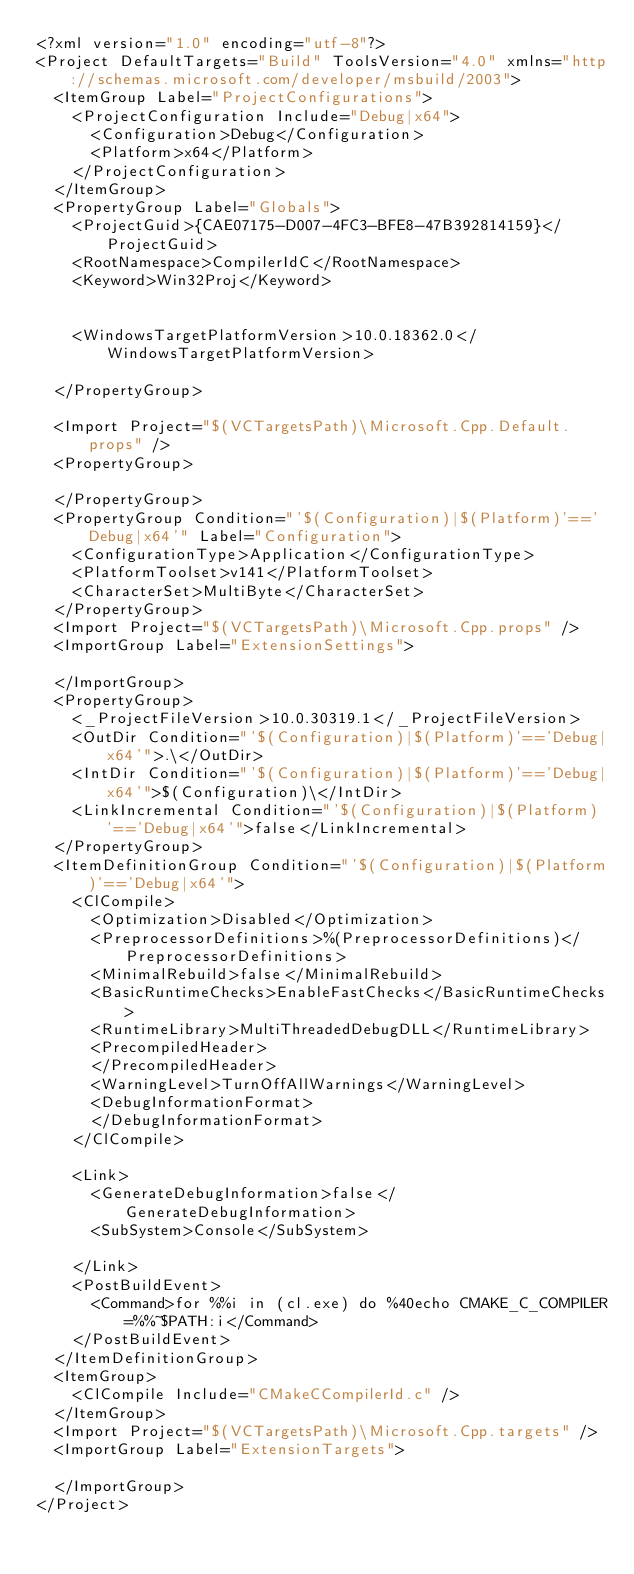Convert code to text. <code><loc_0><loc_0><loc_500><loc_500><_XML_><?xml version="1.0" encoding="utf-8"?>
<Project DefaultTargets="Build" ToolsVersion="4.0" xmlns="http://schemas.microsoft.com/developer/msbuild/2003">
  <ItemGroup Label="ProjectConfigurations">
    <ProjectConfiguration Include="Debug|x64">
      <Configuration>Debug</Configuration>
      <Platform>x64</Platform>
    </ProjectConfiguration>
  </ItemGroup>
  <PropertyGroup Label="Globals">
    <ProjectGuid>{CAE07175-D007-4FC3-BFE8-47B392814159}</ProjectGuid>
    <RootNamespace>CompilerIdC</RootNamespace>
    <Keyword>Win32Proj</Keyword>
    
    
    <WindowsTargetPlatformVersion>10.0.18362.0</WindowsTargetPlatformVersion>
    
  </PropertyGroup>
  
  <Import Project="$(VCTargetsPath)\Microsoft.Cpp.Default.props" />
  <PropertyGroup>
    
  </PropertyGroup>
  <PropertyGroup Condition="'$(Configuration)|$(Platform)'=='Debug|x64'" Label="Configuration">
    <ConfigurationType>Application</ConfigurationType>
    <PlatformToolset>v141</PlatformToolset>
    <CharacterSet>MultiByte</CharacterSet>
  </PropertyGroup>
  <Import Project="$(VCTargetsPath)\Microsoft.Cpp.props" />
  <ImportGroup Label="ExtensionSettings">
    
  </ImportGroup>
  <PropertyGroup>
    <_ProjectFileVersion>10.0.30319.1</_ProjectFileVersion>
    <OutDir Condition="'$(Configuration)|$(Platform)'=='Debug|x64'">.\</OutDir>
    <IntDir Condition="'$(Configuration)|$(Platform)'=='Debug|x64'">$(Configuration)\</IntDir>
    <LinkIncremental Condition="'$(Configuration)|$(Platform)'=='Debug|x64'">false</LinkIncremental>
  </PropertyGroup>
  <ItemDefinitionGroup Condition="'$(Configuration)|$(Platform)'=='Debug|x64'">
    <ClCompile>
      <Optimization>Disabled</Optimization>
      <PreprocessorDefinitions>%(PreprocessorDefinitions)</PreprocessorDefinitions>
      <MinimalRebuild>false</MinimalRebuild>
      <BasicRuntimeChecks>EnableFastChecks</BasicRuntimeChecks>
      <RuntimeLibrary>MultiThreadedDebugDLL</RuntimeLibrary>
      <PrecompiledHeader>
      </PrecompiledHeader>
      <WarningLevel>TurnOffAllWarnings</WarningLevel>
      <DebugInformationFormat>
      </DebugInformationFormat>
    </ClCompile>
    
    <Link>
      <GenerateDebugInformation>false</GenerateDebugInformation>
      <SubSystem>Console</SubSystem>
      
    </Link>
    <PostBuildEvent>
      <Command>for %%i in (cl.exe) do %40echo CMAKE_C_COMPILER=%%~$PATH:i</Command>
    </PostBuildEvent>
  </ItemDefinitionGroup>
  <ItemGroup>
    <ClCompile Include="CMakeCCompilerId.c" />
  </ItemGroup>
  <Import Project="$(VCTargetsPath)\Microsoft.Cpp.targets" />
  <ImportGroup Label="ExtensionTargets">
    
  </ImportGroup>
</Project>
</code> 